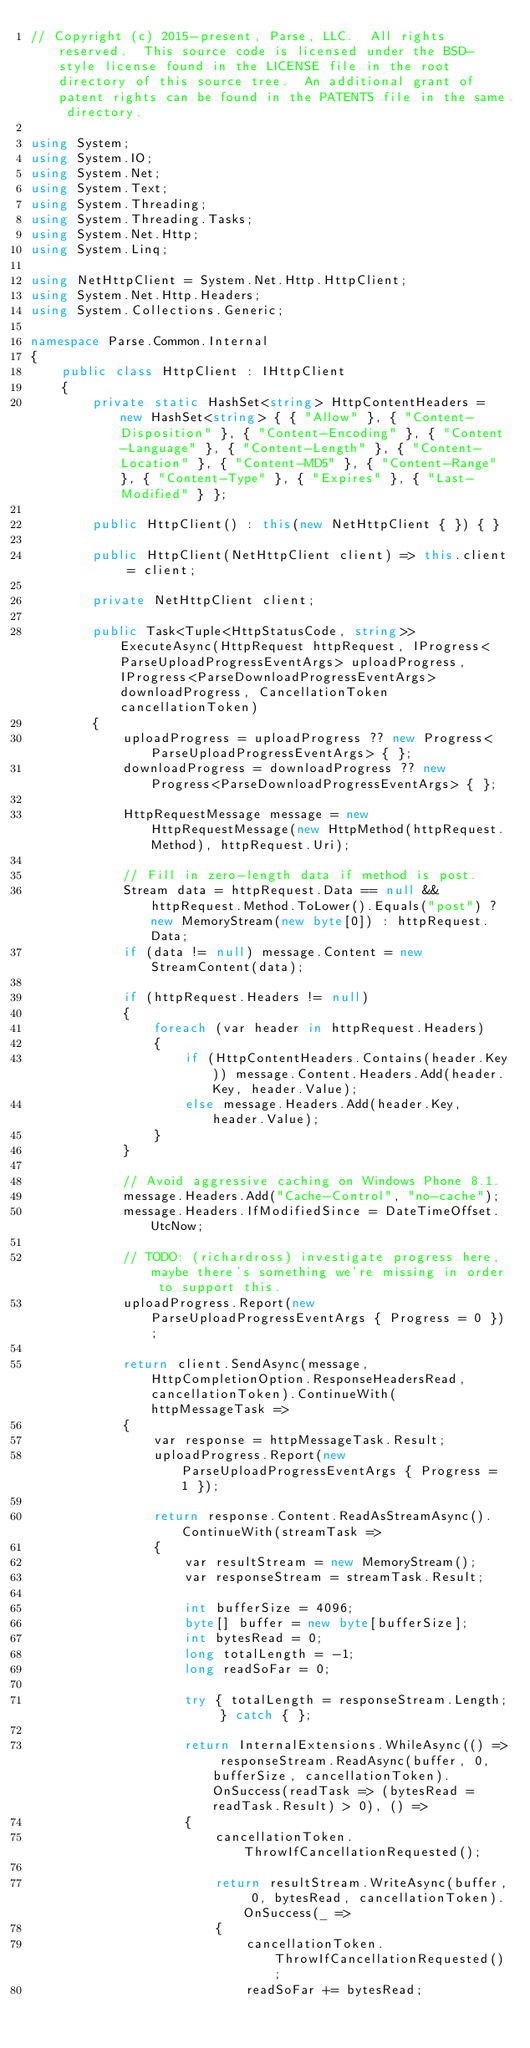Convert code to text. <code><loc_0><loc_0><loc_500><loc_500><_C#_>// Copyright (c) 2015-present, Parse, LLC.  All rights reserved.  This source code is licensed under the BSD-style license found in the LICENSE file in the root directory of this source tree.  An additional grant of patent rights can be found in the PATENTS file in the same directory.

using System;
using System.IO;
using System.Net;
using System.Text;
using System.Threading;
using System.Threading.Tasks;
using System.Net.Http;
using System.Linq;

using NetHttpClient = System.Net.Http.HttpClient;
using System.Net.Http.Headers;
using System.Collections.Generic;

namespace Parse.Common.Internal
{
    public class HttpClient : IHttpClient
    {
        private static HashSet<string> HttpContentHeaders = new HashSet<string> { { "Allow" }, { "Content-Disposition" }, { "Content-Encoding" }, { "Content-Language" }, { "Content-Length" }, { "Content-Location" }, { "Content-MD5" }, { "Content-Range" }, { "Content-Type" }, { "Expires" }, { "Last-Modified" } };

        public HttpClient() : this(new NetHttpClient { }) { }

        public HttpClient(NetHttpClient client) => this.client = client;

        private NetHttpClient client;

        public Task<Tuple<HttpStatusCode, string>> ExecuteAsync(HttpRequest httpRequest, IProgress<ParseUploadProgressEventArgs> uploadProgress, IProgress<ParseDownloadProgressEventArgs> downloadProgress, CancellationToken cancellationToken)
        {
            uploadProgress = uploadProgress ?? new Progress<ParseUploadProgressEventArgs> { };
            downloadProgress = downloadProgress ?? new Progress<ParseDownloadProgressEventArgs> { };

            HttpRequestMessage message = new HttpRequestMessage(new HttpMethod(httpRequest.Method), httpRequest.Uri);

            // Fill in zero-length data if method is post.
            Stream data = httpRequest.Data == null && httpRequest.Method.ToLower().Equals("post") ? new MemoryStream(new byte[0]) : httpRequest.Data;
            if (data != null) message.Content = new StreamContent(data);

            if (httpRequest.Headers != null)
            {
                foreach (var header in httpRequest.Headers)
                {
                    if (HttpContentHeaders.Contains(header.Key)) message.Content.Headers.Add(header.Key, header.Value);
                    else message.Headers.Add(header.Key, header.Value);
                }
            }

            // Avoid aggressive caching on Windows Phone 8.1.
            message.Headers.Add("Cache-Control", "no-cache");
            message.Headers.IfModifiedSince = DateTimeOffset.UtcNow;

            // TODO: (richardross) investigate progress here, maybe there's something we're missing in order to support this.
            uploadProgress.Report(new ParseUploadProgressEventArgs { Progress = 0 });

            return client.SendAsync(message, HttpCompletionOption.ResponseHeadersRead, cancellationToken).ContinueWith(httpMessageTask =>
            {
                var response = httpMessageTask.Result;
                uploadProgress.Report(new ParseUploadProgressEventArgs { Progress = 1 });

                return response.Content.ReadAsStreamAsync().ContinueWith(streamTask =>
                {
                    var resultStream = new MemoryStream();
                    var responseStream = streamTask.Result;

                    int bufferSize = 4096;
                    byte[] buffer = new byte[bufferSize];
                    int bytesRead = 0;
                    long totalLength = -1;
                    long readSoFar = 0;

                    try { totalLength = responseStream.Length; } catch { };

                    return InternalExtensions.WhileAsync(() => responseStream.ReadAsync(buffer, 0, bufferSize, cancellationToken).OnSuccess(readTask => (bytesRead = readTask.Result) > 0), () =>
                    {
                        cancellationToken.ThrowIfCancellationRequested();

                        return resultStream.WriteAsync(buffer, 0, bytesRead, cancellationToken).OnSuccess(_ =>
                        {
                            cancellationToken.ThrowIfCancellationRequested();
                            readSoFar += bytesRead;
</code> 